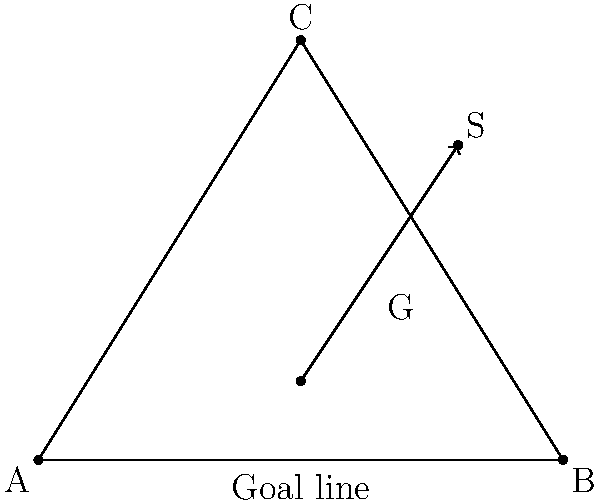In the diagram, ABC represents a goal, with AB being the goal line. Point G represents the goalkeeper's position, and S represents the position of an incoming shot. To maximize the chance of saving the shot, the goalkeeper should position themselves such that the angles AGB and BGS are equal. What is the optimal x-coordinate for the goalkeeper's position G, given that A is at (0,0), B is at (10,0), and S is at (8,6)? Let's approach this step-by-step:

1) We know that for the optimal position, $\angle AGB = \angle BGS$.

2) Let's say the x-coordinate of G is x. Since G is on the goal line, its coordinates are (x, 0).

3) We can use the angle bisector theorem, which states that the angle bisector of an angle of a triangle divides the opposite side in the ratio of the lengths of the other two sides.

4) In this case, AG : GB = AS : BS

5) We can calculate these lengths:
   AG = x
   GB = 10 - x
   AS = $\sqrt{8^2 + 6^2} = \sqrt{100} = 10$
   BS = $\sqrt{2^2 + 6^2} = \sqrt{40} = 2\sqrt{10}$

6) Applying the angle bisector theorem:
   $\frac{x}{10-x} = \frac{10}{2\sqrt{10}}$

7) Cross multiply:
   $2\sqrt{10}x = 10(10-x)$
   $2\sqrt{10}x = 100 - 10x$

8) Solve for x:
   $12\sqrt{10}x = 100$
   $x = \frac{100}{12\sqrt{10}} = \frac{25\sqrt{10}}{30}$

9) This can be simplified to:
   $x = \frac{5\sqrt{10}}{6} \approx 6.38$

Therefore, the optimal x-coordinate for the goalkeeper's position is $\frac{5\sqrt{10}}{6}$.
Answer: $\frac{5\sqrt{10}}{6}$ 